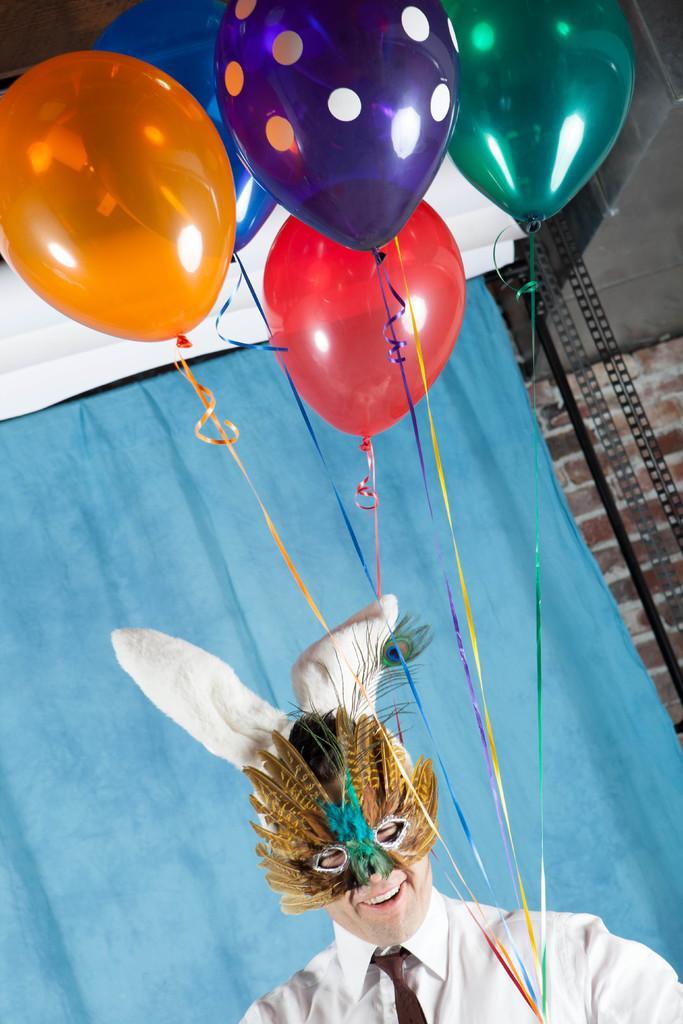Could you give a brief overview of what you see in this image? In this image, we can see a person wearing a costume. We can see some balloons of different colors. We can also see a blue colored cloth and some rods. We can see a white colored object. We can also see the wall. 